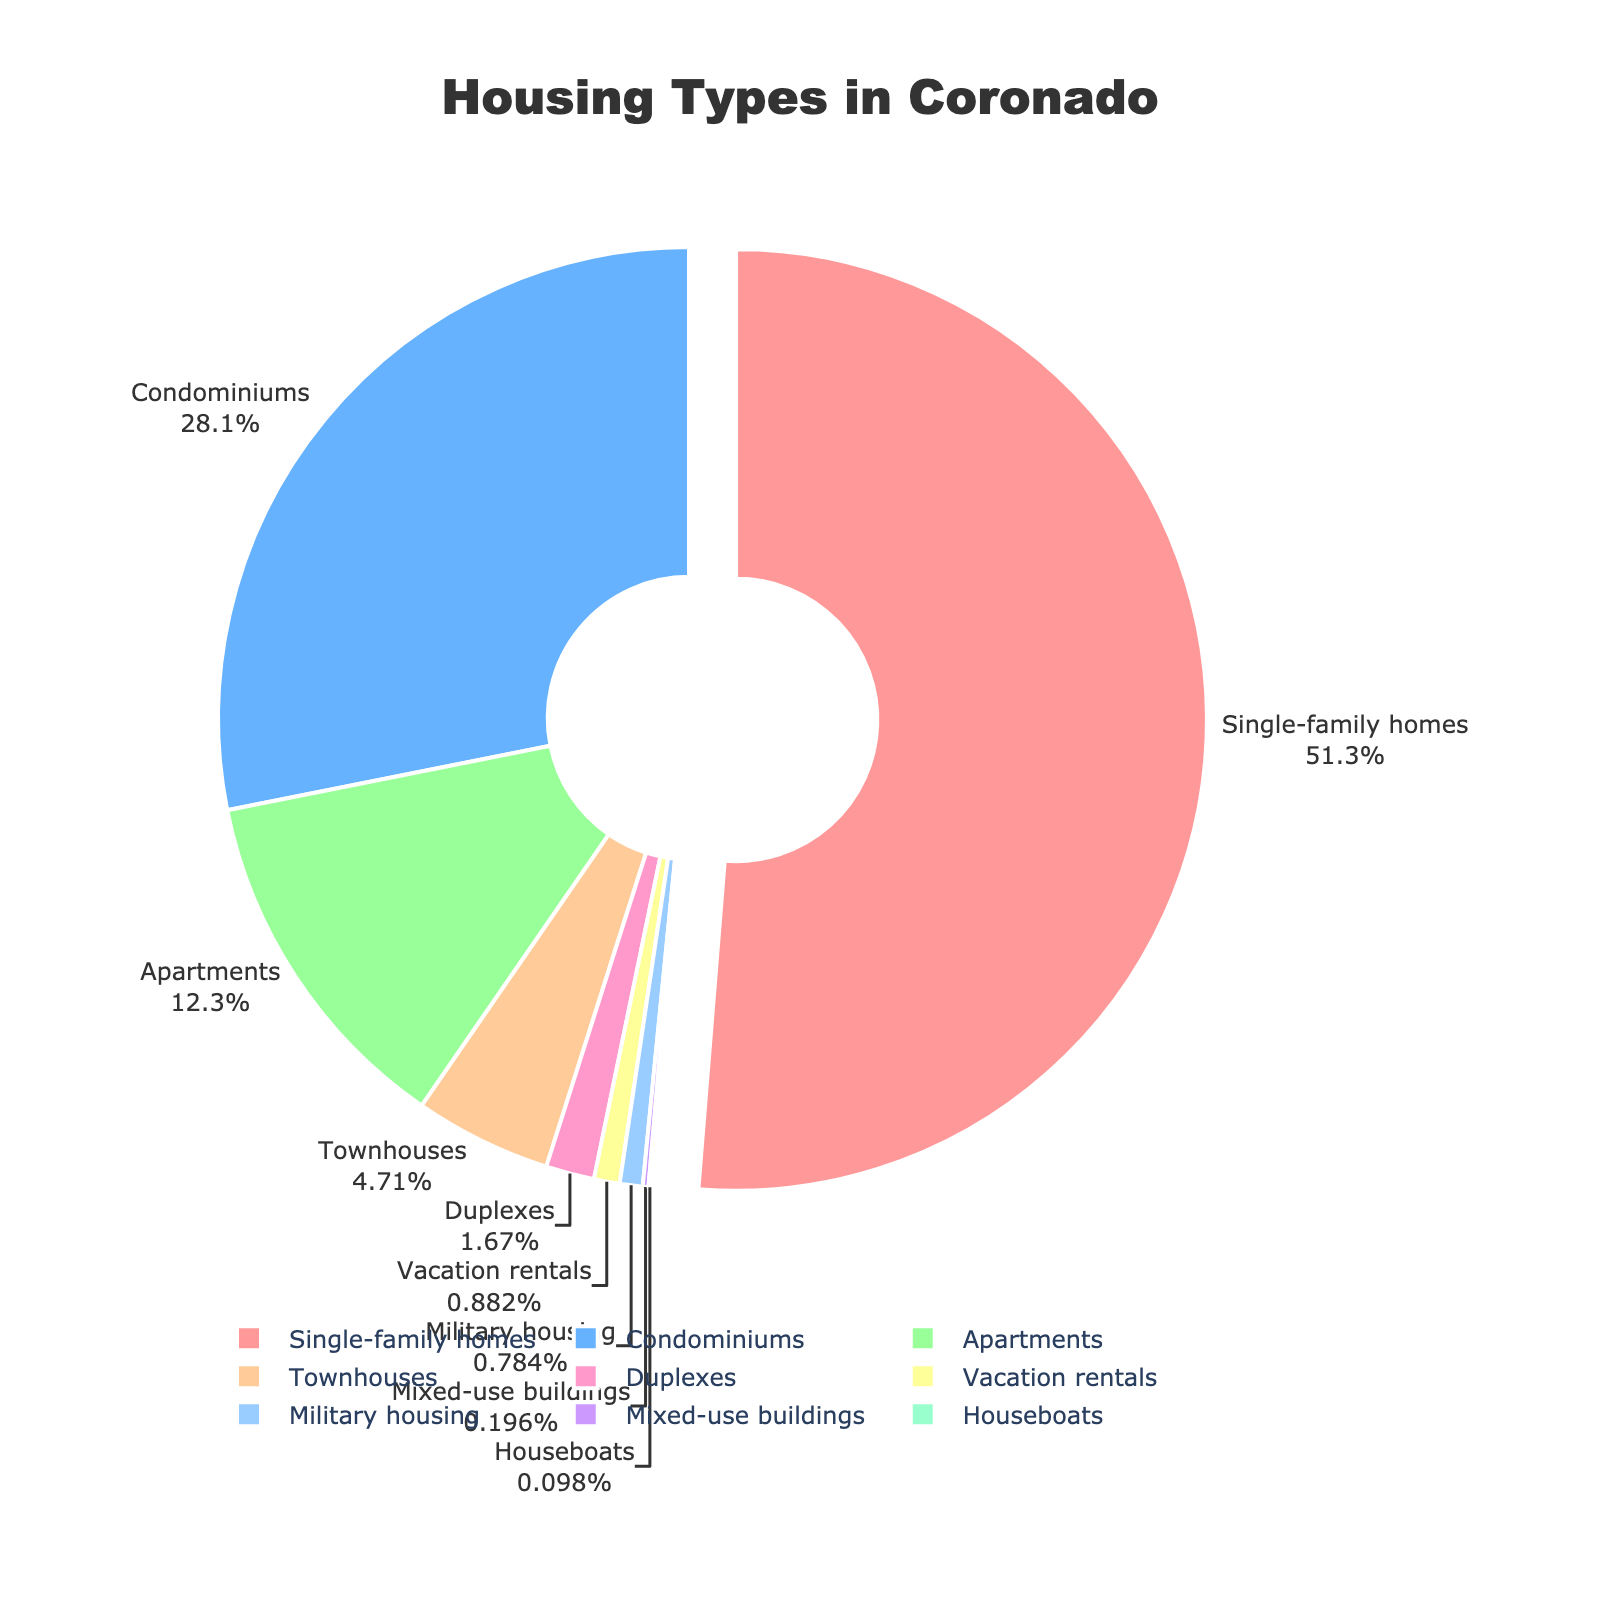What percentage of housing types in Coronado is made up by vacation rentals and mixed-use buildings combined? Vacation rentals account for 0.9% and mixed-use buildings for 0.2%. Adding the two percentages together, 0.9% + 0.2% = 1.1%.
Answer: 1.1% Which housing type has the highest percentage in Coronado? The housing type with the highest percentage is single-family homes, which is visually distinguished by being pulled away slightly from the pie chart, and also has the highest percentage label of 52.3%.
Answer: Single-family homes How does the percentage of apartments compare to townhouses? The percentage of apartments is 12.5%, while townhouses are 4.8%. Therefore, apartments have a larger share.
Answer: Apartments have a larger share What is the combined percentage of single-family homes and condominiums? Single-family homes account for 52.3% and condominiums for 28.7%. Adding these two percentages together, 52.3% + 28.7% = 81.0%.
Answer: 81.0% Identify the housing type with the smallest percentage in Coronado. Houseboats have the smallest percentage, which is 0.1%. This is the lowest value on the pie chart.
Answer: Houseboats How does the percentage of duplexes compare with military housing? Duplexes make up 1.7%, while military housing is at 0.8%. Duplexes therefore have a larger share.
Answer: Duplexes have a larger share What is the color assigned to condominiums in the pie chart? Condominiums are colored blue in the pie chart, as noted visually.
Answer: Blue If apartments and townhouses were combined into a new category, what would their combined percentage be? Apartments are 12.5% and townhouses are 4.8%. Adding these together, the new category would be 12.5% + 4.8% = 17.3%.
Answer: 17.3% Are vacation rentals and military housing percentage shares greater than or less than 2% combined? Vacation rentals are 0.9% and military housing is 0.8%. Combined, they total 0.9% + 0.8% = 1.7%, which is less than 2%.
Answer: Less than 2% What is the average percentage of the three least common housing types in Coronado? The three least common housing types are houseboats (0.1%), mixed-use buildings (0.2%), and vacation rentals (0.9%). Summing these, we get 0.1% + 0.2% + 0.9% = 1.2%. The average is 1.2% / 3 = 0.4%.
Answer: 0.4% 